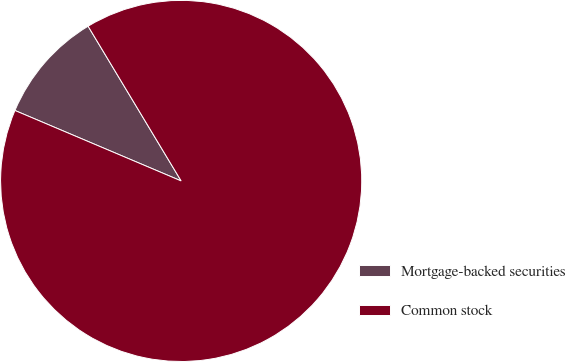Convert chart to OTSL. <chart><loc_0><loc_0><loc_500><loc_500><pie_chart><fcel>Mortgage-backed securities<fcel>Common stock<nl><fcel>10.0%<fcel>90.0%<nl></chart> 